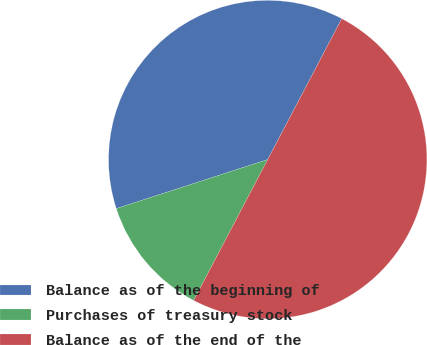Convert chart to OTSL. <chart><loc_0><loc_0><loc_500><loc_500><pie_chart><fcel>Balance as of the beginning of<fcel>Purchases of treasury stock<fcel>Balance as of the end of the<nl><fcel>37.69%<fcel>12.31%<fcel>50.0%<nl></chart> 